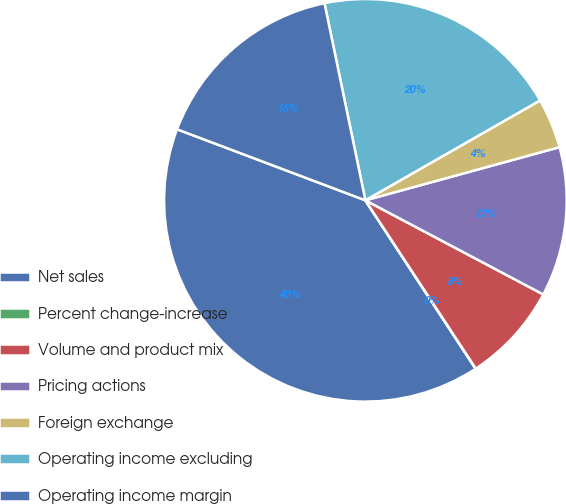<chart> <loc_0><loc_0><loc_500><loc_500><pie_chart><fcel>Net sales<fcel>Percent change-increase<fcel>Volume and product mix<fcel>Pricing actions<fcel>Foreign exchange<fcel>Operating income excluding<fcel>Operating income margin<nl><fcel>39.96%<fcel>0.02%<fcel>8.01%<fcel>12.0%<fcel>4.01%<fcel>19.99%<fcel>16.0%<nl></chart> 